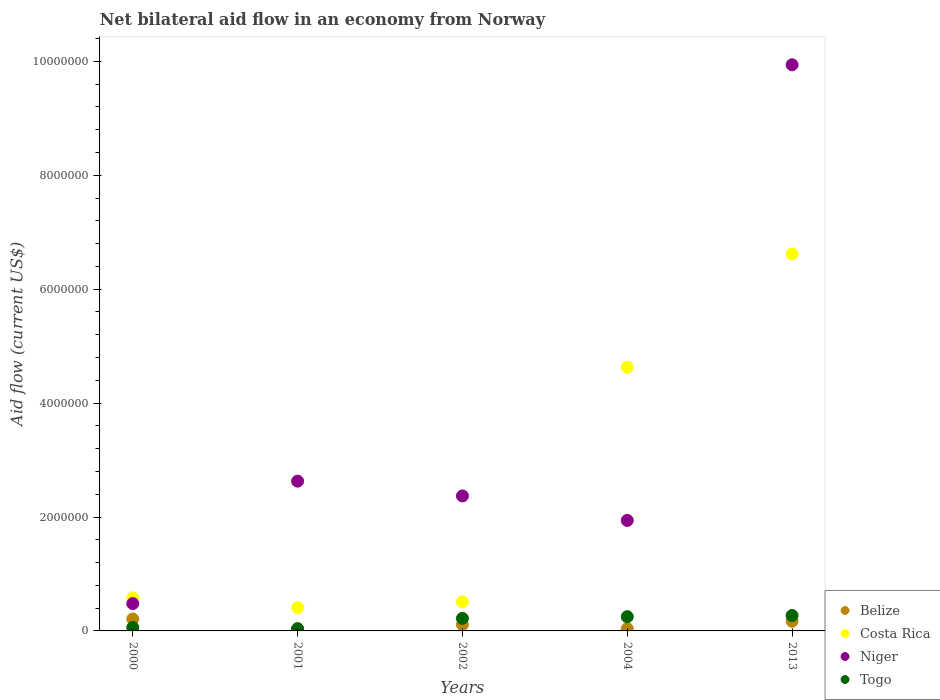What is the net bilateral aid flow in Niger in 2013?
Your answer should be very brief. 9.94e+06. Across all years, what is the maximum net bilateral aid flow in Togo?
Make the answer very short. 2.70e+05. Across all years, what is the minimum net bilateral aid flow in Belize?
Your answer should be compact. 3.00e+04. What is the total net bilateral aid flow in Togo in the graph?
Your response must be concise. 8.40e+05. What is the difference between the net bilateral aid flow in Niger in 2004 and the net bilateral aid flow in Togo in 2001?
Your answer should be compact. 1.90e+06. What is the average net bilateral aid flow in Togo per year?
Your response must be concise. 1.68e+05. In the year 2002, what is the difference between the net bilateral aid flow in Belize and net bilateral aid flow in Niger?
Your answer should be very brief. -2.26e+06. What is the ratio of the net bilateral aid flow in Niger in 2002 to that in 2004?
Your answer should be compact. 1.22. What is the difference between the highest and the lowest net bilateral aid flow in Costa Rica?
Ensure brevity in your answer.  6.21e+06. Is it the case that in every year, the sum of the net bilateral aid flow in Togo and net bilateral aid flow in Costa Rica  is greater than the net bilateral aid flow in Belize?
Ensure brevity in your answer.  Yes. Is the net bilateral aid flow in Costa Rica strictly less than the net bilateral aid flow in Belize over the years?
Ensure brevity in your answer.  No. How many dotlines are there?
Offer a terse response. 4. How many years are there in the graph?
Ensure brevity in your answer.  5. What is the difference between two consecutive major ticks on the Y-axis?
Make the answer very short. 2.00e+06. Are the values on the major ticks of Y-axis written in scientific E-notation?
Your answer should be compact. No. Where does the legend appear in the graph?
Provide a succinct answer. Bottom right. What is the title of the graph?
Provide a succinct answer. Net bilateral aid flow in an economy from Norway. Does "Middle East & North Africa (developing only)" appear as one of the legend labels in the graph?
Provide a succinct answer. No. What is the label or title of the X-axis?
Provide a short and direct response. Years. What is the label or title of the Y-axis?
Provide a short and direct response. Aid flow (current US$). What is the Aid flow (current US$) of Belize in 2000?
Keep it short and to the point. 2.10e+05. What is the Aid flow (current US$) in Costa Rica in 2000?
Make the answer very short. 5.80e+05. What is the Aid flow (current US$) of Niger in 2000?
Offer a very short reply. 4.80e+05. What is the Aid flow (current US$) of Costa Rica in 2001?
Provide a succinct answer. 4.10e+05. What is the Aid flow (current US$) of Niger in 2001?
Ensure brevity in your answer.  2.63e+06. What is the Aid flow (current US$) in Togo in 2001?
Ensure brevity in your answer.  4.00e+04. What is the Aid flow (current US$) in Costa Rica in 2002?
Provide a short and direct response. 5.10e+05. What is the Aid flow (current US$) in Niger in 2002?
Keep it short and to the point. 2.37e+06. What is the Aid flow (current US$) of Costa Rica in 2004?
Keep it short and to the point. 4.63e+06. What is the Aid flow (current US$) in Niger in 2004?
Give a very brief answer. 1.94e+06. What is the Aid flow (current US$) of Togo in 2004?
Offer a terse response. 2.50e+05. What is the Aid flow (current US$) of Costa Rica in 2013?
Offer a terse response. 6.62e+06. What is the Aid flow (current US$) in Niger in 2013?
Your answer should be very brief. 9.94e+06. What is the Aid flow (current US$) in Togo in 2013?
Offer a very short reply. 2.70e+05. Across all years, what is the maximum Aid flow (current US$) in Costa Rica?
Ensure brevity in your answer.  6.62e+06. Across all years, what is the maximum Aid flow (current US$) in Niger?
Offer a very short reply. 9.94e+06. Across all years, what is the minimum Aid flow (current US$) in Belize?
Ensure brevity in your answer.  3.00e+04. Across all years, what is the minimum Aid flow (current US$) of Togo?
Ensure brevity in your answer.  4.00e+04. What is the total Aid flow (current US$) in Belize in the graph?
Give a very brief answer. 5.60e+05. What is the total Aid flow (current US$) in Costa Rica in the graph?
Provide a short and direct response. 1.28e+07. What is the total Aid flow (current US$) in Niger in the graph?
Give a very brief answer. 1.74e+07. What is the total Aid flow (current US$) of Togo in the graph?
Your answer should be compact. 8.40e+05. What is the difference between the Aid flow (current US$) of Belize in 2000 and that in 2001?
Your response must be concise. 1.80e+05. What is the difference between the Aid flow (current US$) in Niger in 2000 and that in 2001?
Offer a terse response. -2.15e+06. What is the difference between the Aid flow (current US$) in Togo in 2000 and that in 2001?
Offer a very short reply. 2.00e+04. What is the difference between the Aid flow (current US$) in Costa Rica in 2000 and that in 2002?
Your answer should be very brief. 7.00e+04. What is the difference between the Aid flow (current US$) of Niger in 2000 and that in 2002?
Offer a terse response. -1.89e+06. What is the difference between the Aid flow (current US$) in Togo in 2000 and that in 2002?
Make the answer very short. -1.60e+05. What is the difference between the Aid flow (current US$) of Costa Rica in 2000 and that in 2004?
Provide a succinct answer. -4.05e+06. What is the difference between the Aid flow (current US$) of Niger in 2000 and that in 2004?
Your answer should be compact. -1.46e+06. What is the difference between the Aid flow (current US$) of Costa Rica in 2000 and that in 2013?
Make the answer very short. -6.04e+06. What is the difference between the Aid flow (current US$) of Niger in 2000 and that in 2013?
Offer a terse response. -9.46e+06. What is the difference between the Aid flow (current US$) in Togo in 2000 and that in 2013?
Your response must be concise. -2.10e+05. What is the difference between the Aid flow (current US$) in Costa Rica in 2001 and that in 2002?
Provide a succinct answer. -1.00e+05. What is the difference between the Aid flow (current US$) in Niger in 2001 and that in 2002?
Offer a very short reply. 2.60e+05. What is the difference between the Aid flow (current US$) of Costa Rica in 2001 and that in 2004?
Give a very brief answer. -4.22e+06. What is the difference between the Aid flow (current US$) of Niger in 2001 and that in 2004?
Provide a succinct answer. 6.90e+05. What is the difference between the Aid flow (current US$) of Togo in 2001 and that in 2004?
Ensure brevity in your answer.  -2.10e+05. What is the difference between the Aid flow (current US$) of Belize in 2001 and that in 2013?
Keep it short and to the point. -1.40e+05. What is the difference between the Aid flow (current US$) in Costa Rica in 2001 and that in 2013?
Offer a terse response. -6.21e+06. What is the difference between the Aid flow (current US$) in Niger in 2001 and that in 2013?
Your response must be concise. -7.31e+06. What is the difference between the Aid flow (current US$) in Belize in 2002 and that in 2004?
Provide a short and direct response. 7.00e+04. What is the difference between the Aid flow (current US$) in Costa Rica in 2002 and that in 2004?
Your response must be concise. -4.12e+06. What is the difference between the Aid flow (current US$) in Togo in 2002 and that in 2004?
Your answer should be very brief. -3.00e+04. What is the difference between the Aid flow (current US$) of Belize in 2002 and that in 2013?
Make the answer very short. -6.00e+04. What is the difference between the Aid flow (current US$) of Costa Rica in 2002 and that in 2013?
Make the answer very short. -6.11e+06. What is the difference between the Aid flow (current US$) in Niger in 2002 and that in 2013?
Keep it short and to the point. -7.57e+06. What is the difference between the Aid flow (current US$) of Belize in 2004 and that in 2013?
Provide a short and direct response. -1.30e+05. What is the difference between the Aid flow (current US$) of Costa Rica in 2004 and that in 2013?
Give a very brief answer. -1.99e+06. What is the difference between the Aid flow (current US$) of Niger in 2004 and that in 2013?
Your response must be concise. -8.00e+06. What is the difference between the Aid flow (current US$) of Belize in 2000 and the Aid flow (current US$) of Niger in 2001?
Offer a terse response. -2.42e+06. What is the difference between the Aid flow (current US$) of Belize in 2000 and the Aid flow (current US$) of Togo in 2001?
Your response must be concise. 1.70e+05. What is the difference between the Aid flow (current US$) of Costa Rica in 2000 and the Aid flow (current US$) of Niger in 2001?
Offer a very short reply. -2.05e+06. What is the difference between the Aid flow (current US$) of Costa Rica in 2000 and the Aid flow (current US$) of Togo in 2001?
Your response must be concise. 5.40e+05. What is the difference between the Aid flow (current US$) of Belize in 2000 and the Aid flow (current US$) of Costa Rica in 2002?
Provide a short and direct response. -3.00e+05. What is the difference between the Aid flow (current US$) in Belize in 2000 and the Aid flow (current US$) in Niger in 2002?
Provide a short and direct response. -2.16e+06. What is the difference between the Aid flow (current US$) of Costa Rica in 2000 and the Aid flow (current US$) of Niger in 2002?
Offer a terse response. -1.79e+06. What is the difference between the Aid flow (current US$) of Niger in 2000 and the Aid flow (current US$) of Togo in 2002?
Provide a short and direct response. 2.60e+05. What is the difference between the Aid flow (current US$) in Belize in 2000 and the Aid flow (current US$) in Costa Rica in 2004?
Ensure brevity in your answer.  -4.42e+06. What is the difference between the Aid flow (current US$) of Belize in 2000 and the Aid flow (current US$) of Niger in 2004?
Your answer should be compact. -1.73e+06. What is the difference between the Aid flow (current US$) of Belize in 2000 and the Aid flow (current US$) of Togo in 2004?
Offer a very short reply. -4.00e+04. What is the difference between the Aid flow (current US$) in Costa Rica in 2000 and the Aid flow (current US$) in Niger in 2004?
Make the answer very short. -1.36e+06. What is the difference between the Aid flow (current US$) in Belize in 2000 and the Aid flow (current US$) in Costa Rica in 2013?
Provide a short and direct response. -6.41e+06. What is the difference between the Aid flow (current US$) in Belize in 2000 and the Aid flow (current US$) in Niger in 2013?
Your answer should be compact. -9.73e+06. What is the difference between the Aid flow (current US$) of Belize in 2000 and the Aid flow (current US$) of Togo in 2013?
Make the answer very short. -6.00e+04. What is the difference between the Aid flow (current US$) of Costa Rica in 2000 and the Aid flow (current US$) of Niger in 2013?
Keep it short and to the point. -9.36e+06. What is the difference between the Aid flow (current US$) in Costa Rica in 2000 and the Aid flow (current US$) in Togo in 2013?
Offer a very short reply. 3.10e+05. What is the difference between the Aid flow (current US$) in Niger in 2000 and the Aid flow (current US$) in Togo in 2013?
Your response must be concise. 2.10e+05. What is the difference between the Aid flow (current US$) in Belize in 2001 and the Aid flow (current US$) in Costa Rica in 2002?
Provide a succinct answer. -4.80e+05. What is the difference between the Aid flow (current US$) in Belize in 2001 and the Aid flow (current US$) in Niger in 2002?
Give a very brief answer. -2.34e+06. What is the difference between the Aid flow (current US$) of Costa Rica in 2001 and the Aid flow (current US$) of Niger in 2002?
Your answer should be very brief. -1.96e+06. What is the difference between the Aid flow (current US$) in Niger in 2001 and the Aid flow (current US$) in Togo in 2002?
Ensure brevity in your answer.  2.41e+06. What is the difference between the Aid flow (current US$) in Belize in 2001 and the Aid flow (current US$) in Costa Rica in 2004?
Your answer should be compact. -4.60e+06. What is the difference between the Aid flow (current US$) in Belize in 2001 and the Aid flow (current US$) in Niger in 2004?
Offer a very short reply. -1.91e+06. What is the difference between the Aid flow (current US$) of Costa Rica in 2001 and the Aid flow (current US$) of Niger in 2004?
Offer a terse response. -1.53e+06. What is the difference between the Aid flow (current US$) in Niger in 2001 and the Aid flow (current US$) in Togo in 2004?
Provide a succinct answer. 2.38e+06. What is the difference between the Aid flow (current US$) of Belize in 2001 and the Aid flow (current US$) of Costa Rica in 2013?
Offer a terse response. -6.59e+06. What is the difference between the Aid flow (current US$) of Belize in 2001 and the Aid flow (current US$) of Niger in 2013?
Make the answer very short. -9.91e+06. What is the difference between the Aid flow (current US$) in Costa Rica in 2001 and the Aid flow (current US$) in Niger in 2013?
Make the answer very short. -9.53e+06. What is the difference between the Aid flow (current US$) of Niger in 2001 and the Aid flow (current US$) of Togo in 2013?
Make the answer very short. 2.36e+06. What is the difference between the Aid flow (current US$) in Belize in 2002 and the Aid flow (current US$) in Costa Rica in 2004?
Keep it short and to the point. -4.52e+06. What is the difference between the Aid flow (current US$) in Belize in 2002 and the Aid flow (current US$) in Niger in 2004?
Your answer should be very brief. -1.83e+06. What is the difference between the Aid flow (current US$) in Belize in 2002 and the Aid flow (current US$) in Togo in 2004?
Your answer should be very brief. -1.40e+05. What is the difference between the Aid flow (current US$) in Costa Rica in 2002 and the Aid flow (current US$) in Niger in 2004?
Ensure brevity in your answer.  -1.43e+06. What is the difference between the Aid flow (current US$) in Costa Rica in 2002 and the Aid flow (current US$) in Togo in 2004?
Offer a very short reply. 2.60e+05. What is the difference between the Aid flow (current US$) of Niger in 2002 and the Aid flow (current US$) of Togo in 2004?
Make the answer very short. 2.12e+06. What is the difference between the Aid flow (current US$) of Belize in 2002 and the Aid flow (current US$) of Costa Rica in 2013?
Your answer should be compact. -6.51e+06. What is the difference between the Aid flow (current US$) of Belize in 2002 and the Aid flow (current US$) of Niger in 2013?
Your response must be concise. -9.83e+06. What is the difference between the Aid flow (current US$) in Belize in 2002 and the Aid flow (current US$) in Togo in 2013?
Provide a succinct answer. -1.60e+05. What is the difference between the Aid flow (current US$) in Costa Rica in 2002 and the Aid flow (current US$) in Niger in 2013?
Offer a terse response. -9.43e+06. What is the difference between the Aid flow (current US$) of Costa Rica in 2002 and the Aid flow (current US$) of Togo in 2013?
Ensure brevity in your answer.  2.40e+05. What is the difference between the Aid flow (current US$) in Niger in 2002 and the Aid flow (current US$) in Togo in 2013?
Provide a succinct answer. 2.10e+06. What is the difference between the Aid flow (current US$) of Belize in 2004 and the Aid flow (current US$) of Costa Rica in 2013?
Your response must be concise. -6.58e+06. What is the difference between the Aid flow (current US$) of Belize in 2004 and the Aid flow (current US$) of Niger in 2013?
Offer a terse response. -9.90e+06. What is the difference between the Aid flow (current US$) in Costa Rica in 2004 and the Aid flow (current US$) in Niger in 2013?
Give a very brief answer. -5.31e+06. What is the difference between the Aid flow (current US$) in Costa Rica in 2004 and the Aid flow (current US$) in Togo in 2013?
Keep it short and to the point. 4.36e+06. What is the difference between the Aid flow (current US$) in Niger in 2004 and the Aid flow (current US$) in Togo in 2013?
Give a very brief answer. 1.67e+06. What is the average Aid flow (current US$) in Belize per year?
Your answer should be very brief. 1.12e+05. What is the average Aid flow (current US$) in Costa Rica per year?
Provide a short and direct response. 2.55e+06. What is the average Aid flow (current US$) in Niger per year?
Ensure brevity in your answer.  3.47e+06. What is the average Aid flow (current US$) of Togo per year?
Your answer should be very brief. 1.68e+05. In the year 2000, what is the difference between the Aid flow (current US$) of Belize and Aid flow (current US$) of Costa Rica?
Provide a short and direct response. -3.70e+05. In the year 2000, what is the difference between the Aid flow (current US$) in Costa Rica and Aid flow (current US$) in Niger?
Your answer should be compact. 1.00e+05. In the year 2000, what is the difference between the Aid flow (current US$) of Costa Rica and Aid flow (current US$) of Togo?
Your answer should be compact. 5.20e+05. In the year 2001, what is the difference between the Aid flow (current US$) in Belize and Aid flow (current US$) in Costa Rica?
Offer a very short reply. -3.80e+05. In the year 2001, what is the difference between the Aid flow (current US$) in Belize and Aid flow (current US$) in Niger?
Offer a very short reply. -2.60e+06. In the year 2001, what is the difference between the Aid flow (current US$) of Belize and Aid flow (current US$) of Togo?
Your answer should be compact. -10000. In the year 2001, what is the difference between the Aid flow (current US$) in Costa Rica and Aid flow (current US$) in Niger?
Offer a terse response. -2.22e+06. In the year 2001, what is the difference between the Aid flow (current US$) of Costa Rica and Aid flow (current US$) of Togo?
Keep it short and to the point. 3.70e+05. In the year 2001, what is the difference between the Aid flow (current US$) of Niger and Aid flow (current US$) of Togo?
Provide a short and direct response. 2.59e+06. In the year 2002, what is the difference between the Aid flow (current US$) in Belize and Aid flow (current US$) in Costa Rica?
Your response must be concise. -4.00e+05. In the year 2002, what is the difference between the Aid flow (current US$) in Belize and Aid flow (current US$) in Niger?
Keep it short and to the point. -2.26e+06. In the year 2002, what is the difference between the Aid flow (current US$) in Belize and Aid flow (current US$) in Togo?
Your answer should be compact. -1.10e+05. In the year 2002, what is the difference between the Aid flow (current US$) of Costa Rica and Aid flow (current US$) of Niger?
Ensure brevity in your answer.  -1.86e+06. In the year 2002, what is the difference between the Aid flow (current US$) of Costa Rica and Aid flow (current US$) of Togo?
Your answer should be very brief. 2.90e+05. In the year 2002, what is the difference between the Aid flow (current US$) in Niger and Aid flow (current US$) in Togo?
Ensure brevity in your answer.  2.15e+06. In the year 2004, what is the difference between the Aid flow (current US$) of Belize and Aid flow (current US$) of Costa Rica?
Keep it short and to the point. -4.59e+06. In the year 2004, what is the difference between the Aid flow (current US$) of Belize and Aid flow (current US$) of Niger?
Provide a short and direct response. -1.90e+06. In the year 2004, what is the difference between the Aid flow (current US$) in Costa Rica and Aid flow (current US$) in Niger?
Offer a terse response. 2.69e+06. In the year 2004, what is the difference between the Aid flow (current US$) of Costa Rica and Aid flow (current US$) of Togo?
Give a very brief answer. 4.38e+06. In the year 2004, what is the difference between the Aid flow (current US$) of Niger and Aid flow (current US$) of Togo?
Offer a terse response. 1.69e+06. In the year 2013, what is the difference between the Aid flow (current US$) of Belize and Aid flow (current US$) of Costa Rica?
Ensure brevity in your answer.  -6.45e+06. In the year 2013, what is the difference between the Aid flow (current US$) in Belize and Aid flow (current US$) in Niger?
Provide a short and direct response. -9.77e+06. In the year 2013, what is the difference between the Aid flow (current US$) of Belize and Aid flow (current US$) of Togo?
Provide a succinct answer. -1.00e+05. In the year 2013, what is the difference between the Aid flow (current US$) in Costa Rica and Aid flow (current US$) in Niger?
Your response must be concise. -3.32e+06. In the year 2013, what is the difference between the Aid flow (current US$) in Costa Rica and Aid flow (current US$) in Togo?
Give a very brief answer. 6.35e+06. In the year 2013, what is the difference between the Aid flow (current US$) of Niger and Aid flow (current US$) of Togo?
Your answer should be compact. 9.67e+06. What is the ratio of the Aid flow (current US$) in Belize in 2000 to that in 2001?
Your answer should be very brief. 7. What is the ratio of the Aid flow (current US$) of Costa Rica in 2000 to that in 2001?
Make the answer very short. 1.41. What is the ratio of the Aid flow (current US$) in Niger in 2000 to that in 2001?
Make the answer very short. 0.18. What is the ratio of the Aid flow (current US$) of Togo in 2000 to that in 2001?
Offer a terse response. 1.5. What is the ratio of the Aid flow (current US$) of Belize in 2000 to that in 2002?
Ensure brevity in your answer.  1.91. What is the ratio of the Aid flow (current US$) of Costa Rica in 2000 to that in 2002?
Ensure brevity in your answer.  1.14. What is the ratio of the Aid flow (current US$) of Niger in 2000 to that in 2002?
Offer a terse response. 0.2. What is the ratio of the Aid flow (current US$) in Togo in 2000 to that in 2002?
Make the answer very short. 0.27. What is the ratio of the Aid flow (current US$) of Belize in 2000 to that in 2004?
Your response must be concise. 5.25. What is the ratio of the Aid flow (current US$) of Costa Rica in 2000 to that in 2004?
Provide a short and direct response. 0.13. What is the ratio of the Aid flow (current US$) in Niger in 2000 to that in 2004?
Ensure brevity in your answer.  0.25. What is the ratio of the Aid flow (current US$) of Togo in 2000 to that in 2004?
Make the answer very short. 0.24. What is the ratio of the Aid flow (current US$) of Belize in 2000 to that in 2013?
Provide a succinct answer. 1.24. What is the ratio of the Aid flow (current US$) in Costa Rica in 2000 to that in 2013?
Provide a short and direct response. 0.09. What is the ratio of the Aid flow (current US$) of Niger in 2000 to that in 2013?
Offer a terse response. 0.05. What is the ratio of the Aid flow (current US$) of Togo in 2000 to that in 2013?
Provide a succinct answer. 0.22. What is the ratio of the Aid flow (current US$) in Belize in 2001 to that in 2002?
Provide a succinct answer. 0.27. What is the ratio of the Aid flow (current US$) in Costa Rica in 2001 to that in 2002?
Keep it short and to the point. 0.8. What is the ratio of the Aid flow (current US$) in Niger in 2001 to that in 2002?
Ensure brevity in your answer.  1.11. What is the ratio of the Aid flow (current US$) of Togo in 2001 to that in 2002?
Provide a succinct answer. 0.18. What is the ratio of the Aid flow (current US$) in Belize in 2001 to that in 2004?
Provide a short and direct response. 0.75. What is the ratio of the Aid flow (current US$) in Costa Rica in 2001 to that in 2004?
Make the answer very short. 0.09. What is the ratio of the Aid flow (current US$) of Niger in 2001 to that in 2004?
Make the answer very short. 1.36. What is the ratio of the Aid flow (current US$) in Togo in 2001 to that in 2004?
Ensure brevity in your answer.  0.16. What is the ratio of the Aid flow (current US$) in Belize in 2001 to that in 2013?
Your response must be concise. 0.18. What is the ratio of the Aid flow (current US$) of Costa Rica in 2001 to that in 2013?
Keep it short and to the point. 0.06. What is the ratio of the Aid flow (current US$) of Niger in 2001 to that in 2013?
Provide a succinct answer. 0.26. What is the ratio of the Aid flow (current US$) in Togo in 2001 to that in 2013?
Your answer should be very brief. 0.15. What is the ratio of the Aid flow (current US$) in Belize in 2002 to that in 2004?
Your answer should be compact. 2.75. What is the ratio of the Aid flow (current US$) in Costa Rica in 2002 to that in 2004?
Provide a short and direct response. 0.11. What is the ratio of the Aid flow (current US$) of Niger in 2002 to that in 2004?
Your answer should be very brief. 1.22. What is the ratio of the Aid flow (current US$) in Togo in 2002 to that in 2004?
Keep it short and to the point. 0.88. What is the ratio of the Aid flow (current US$) in Belize in 2002 to that in 2013?
Offer a terse response. 0.65. What is the ratio of the Aid flow (current US$) in Costa Rica in 2002 to that in 2013?
Ensure brevity in your answer.  0.08. What is the ratio of the Aid flow (current US$) in Niger in 2002 to that in 2013?
Keep it short and to the point. 0.24. What is the ratio of the Aid flow (current US$) in Togo in 2002 to that in 2013?
Offer a very short reply. 0.81. What is the ratio of the Aid flow (current US$) in Belize in 2004 to that in 2013?
Provide a short and direct response. 0.24. What is the ratio of the Aid flow (current US$) in Costa Rica in 2004 to that in 2013?
Your answer should be very brief. 0.7. What is the ratio of the Aid flow (current US$) of Niger in 2004 to that in 2013?
Your response must be concise. 0.2. What is the ratio of the Aid flow (current US$) in Togo in 2004 to that in 2013?
Give a very brief answer. 0.93. What is the difference between the highest and the second highest Aid flow (current US$) of Belize?
Your answer should be compact. 4.00e+04. What is the difference between the highest and the second highest Aid flow (current US$) of Costa Rica?
Make the answer very short. 1.99e+06. What is the difference between the highest and the second highest Aid flow (current US$) in Niger?
Provide a succinct answer. 7.31e+06. What is the difference between the highest and the lowest Aid flow (current US$) of Belize?
Give a very brief answer. 1.80e+05. What is the difference between the highest and the lowest Aid flow (current US$) in Costa Rica?
Offer a terse response. 6.21e+06. What is the difference between the highest and the lowest Aid flow (current US$) in Niger?
Ensure brevity in your answer.  9.46e+06. 